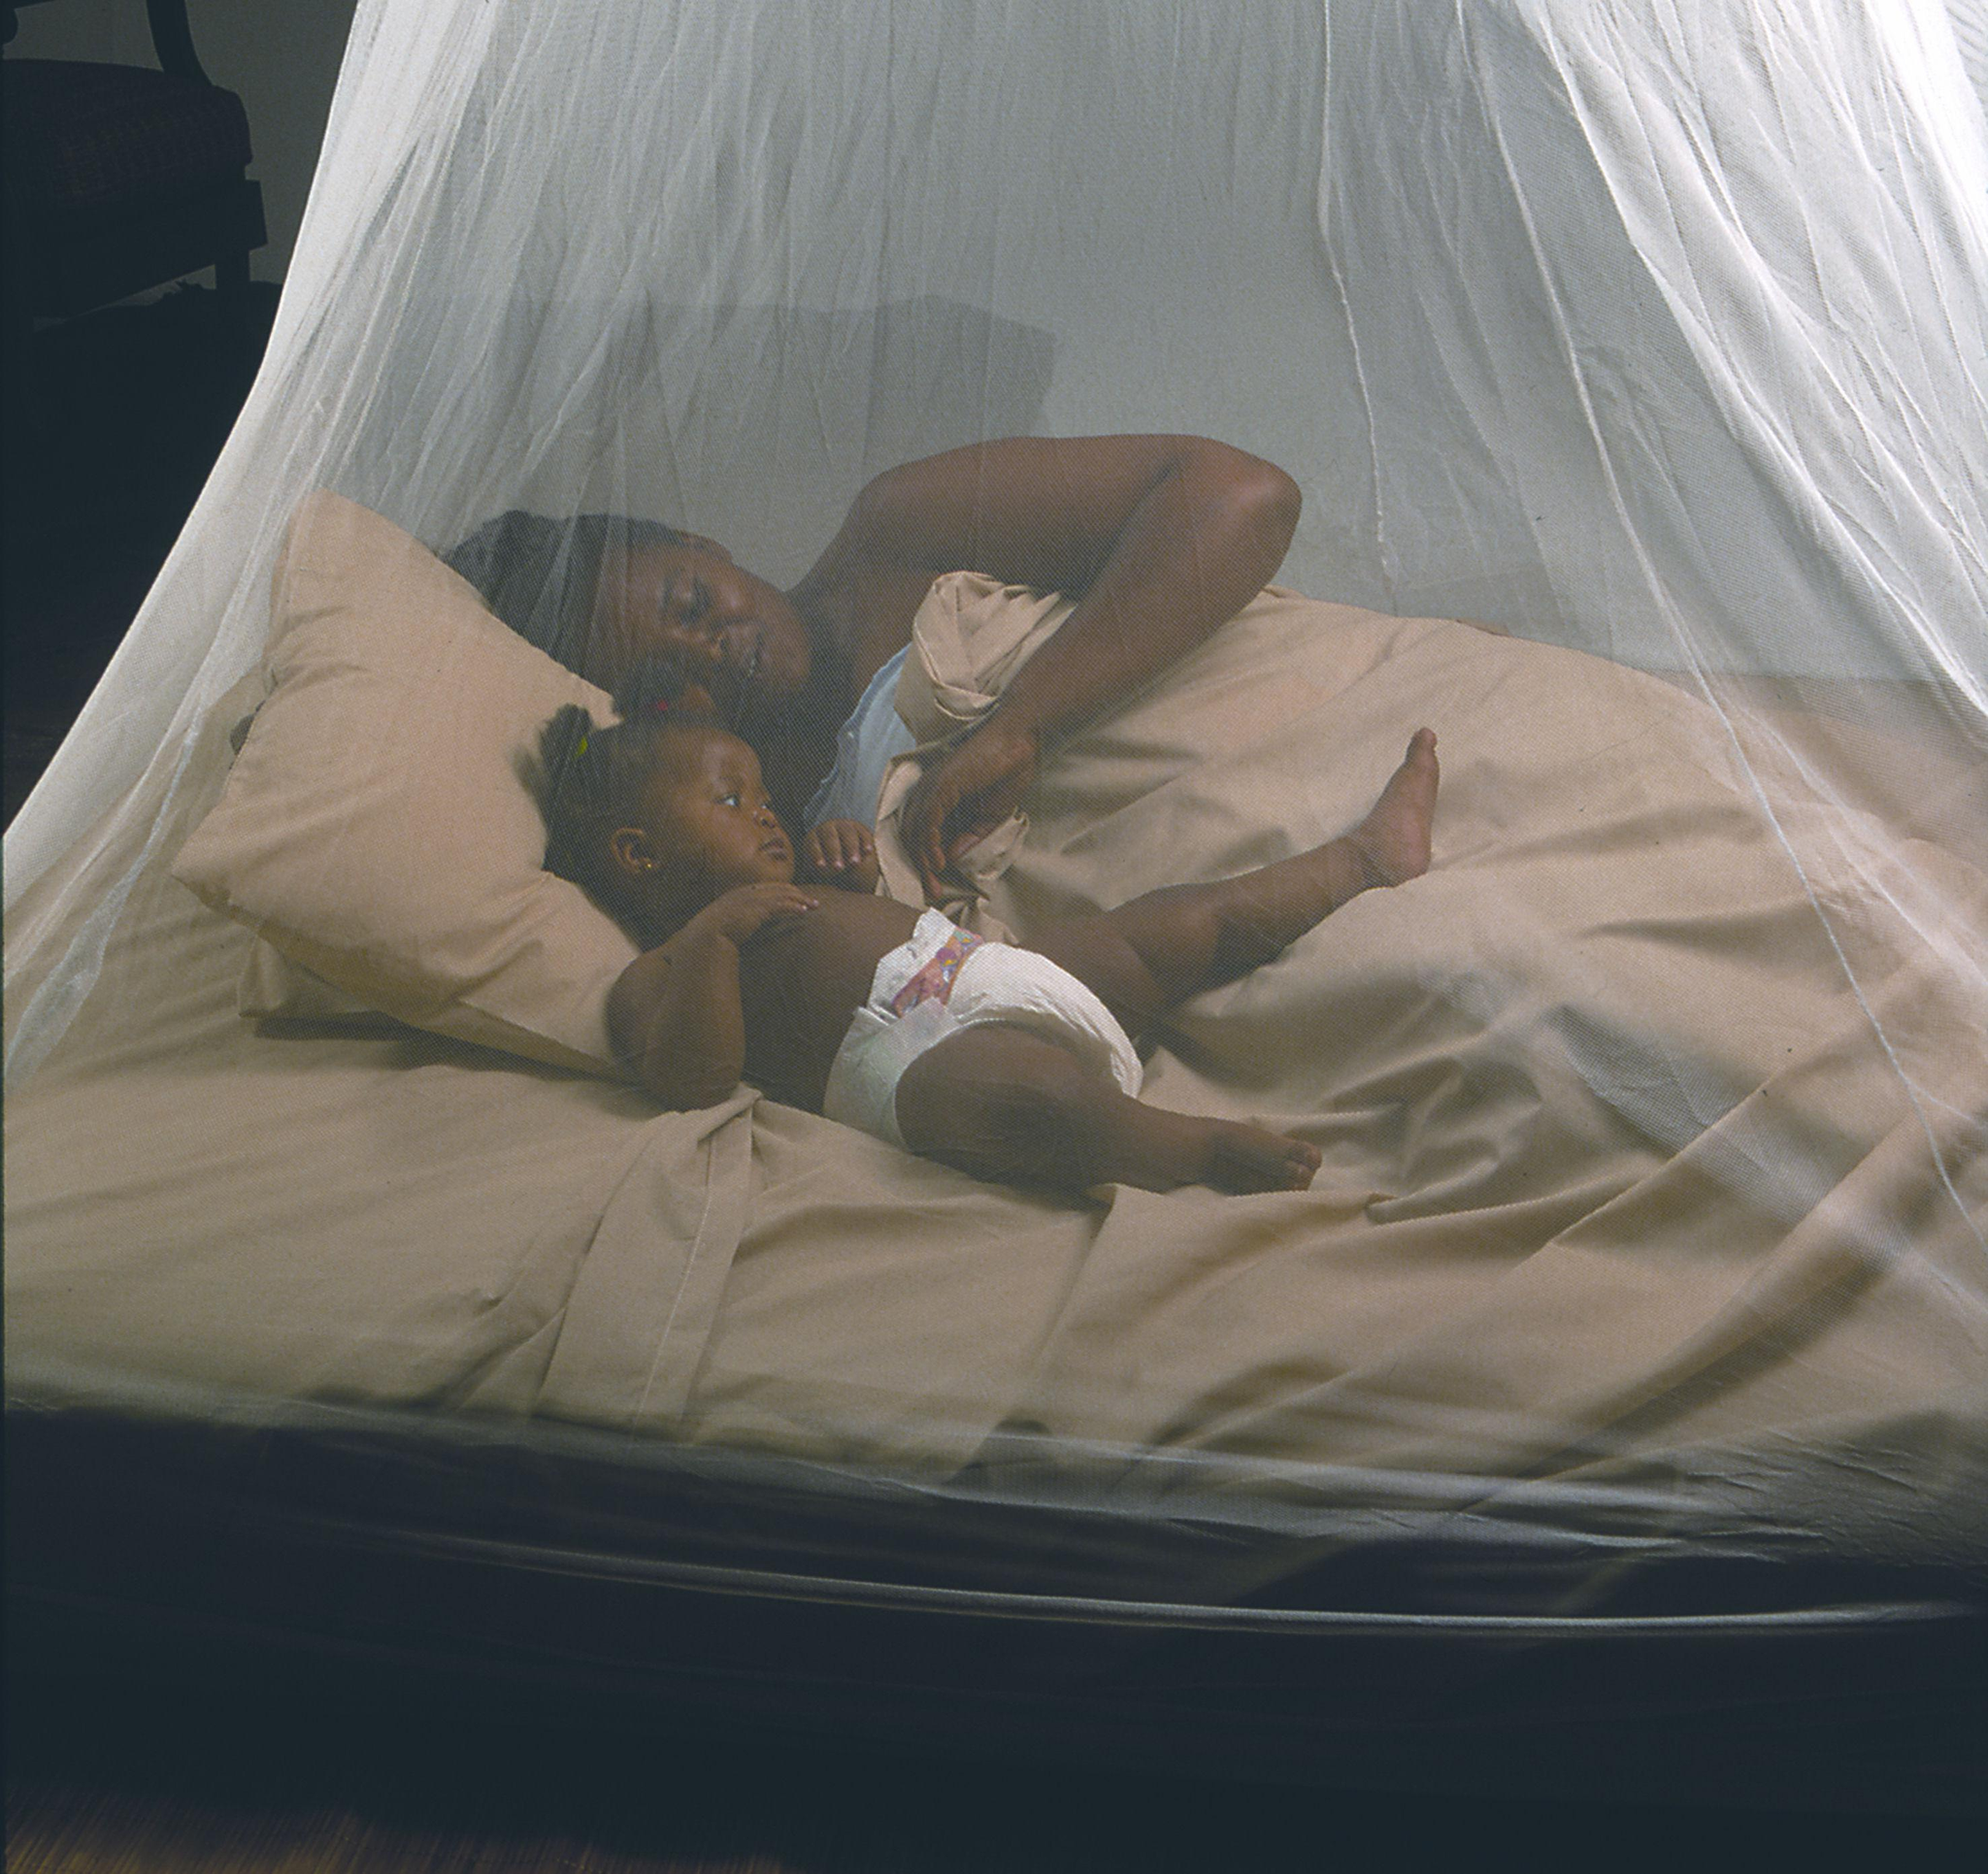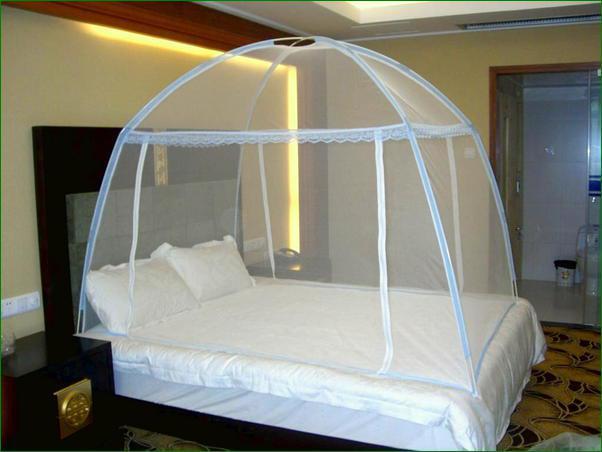The first image is the image on the left, the second image is the image on the right. For the images displayed, is the sentence "There is a round canopy bed in the right image." factually correct? Answer yes or no. No. The first image is the image on the left, the second image is the image on the right. Considering the images on both sides, is "One image shows a gauzy pale canopy that drapes a bed from a round shape suspended from the ceiling, and the other image shows a canopy suspended from four corners." valid? Answer yes or no. No. 